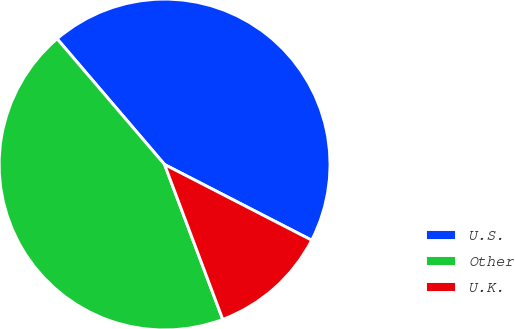Convert chart. <chart><loc_0><loc_0><loc_500><loc_500><pie_chart><fcel>U.S.<fcel>Other<fcel>U.K.<nl><fcel>43.82%<fcel>44.47%<fcel>11.72%<nl></chart> 